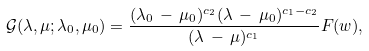Convert formula to latex. <formula><loc_0><loc_0><loc_500><loc_500>\mathcal { G } ( \lambda , \mu ; \lambda _ { 0 } , \mu _ { 0 } ) = \frac { ( \lambda _ { 0 } \, - \, \mu _ { 0 } ) ^ { c _ { 2 } } ( \lambda \, - \, \mu _ { 0 } ) ^ { c _ { 1 } - c _ { 2 } } } { ( \lambda \, - \, \mu ) ^ { c _ { 1 } } } F ( w ) ,</formula> 